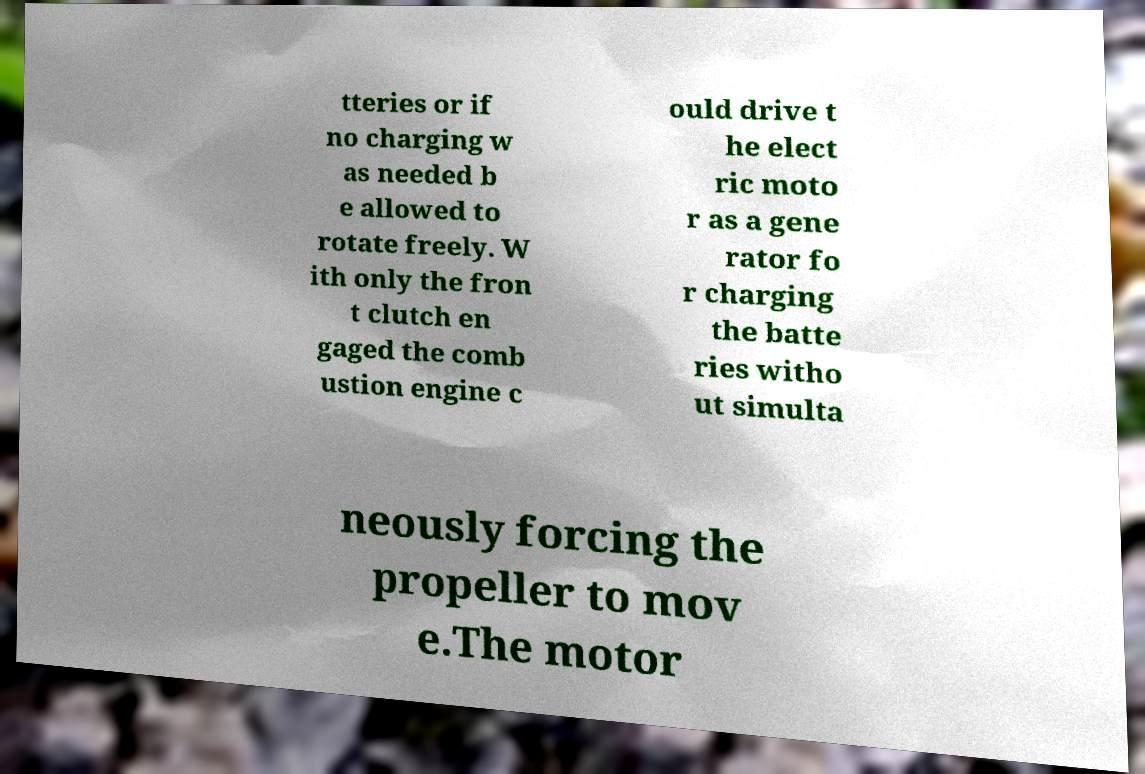I need the written content from this picture converted into text. Can you do that? tteries or if no charging w as needed b e allowed to rotate freely. W ith only the fron t clutch en gaged the comb ustion engine c ould drive t he elect ric moto r as a gene rator fo r charging the batte ries witho ut simulta neously forcing the propeller to mov e.The motor 